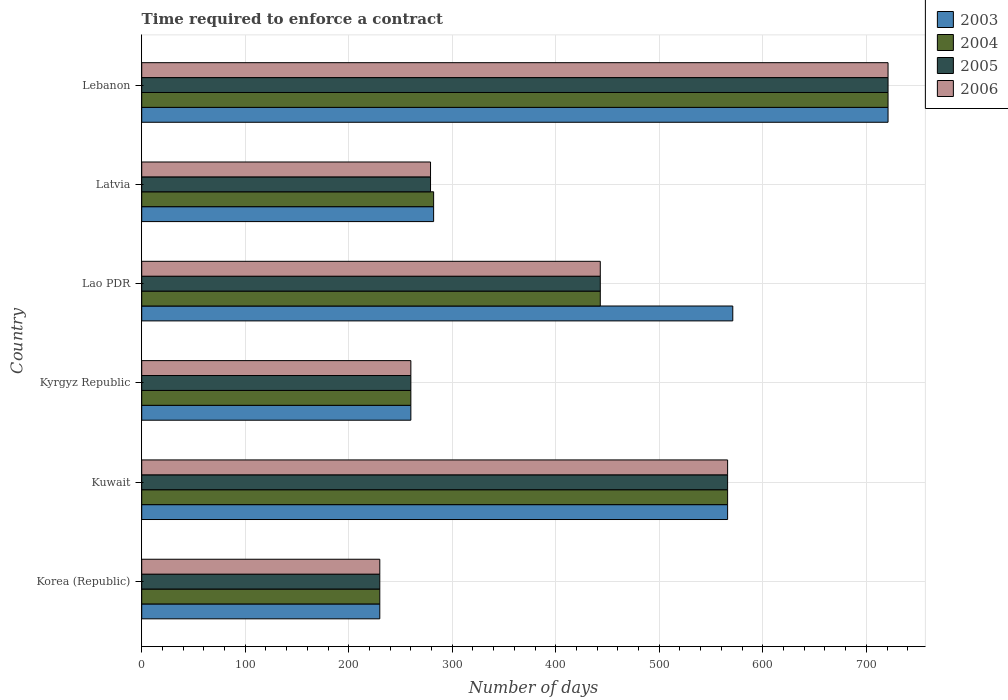How many different coloured bars are there?
Offer a terse response. 4. Are the number of bars per tick equal to the number of legend labels?
Provide a succinct answer. Yes. How many bars are there on the 1st tick from the top?
Your response must be concise. 4. How many bars are there on the 2nd tick from the bottom?
Make the answer very short. 4. What is the label of the 2nd group of bars from the top?
Your answer should be compact. Latvia. In how many cases, is the number of bars for a given country not equal to the number of legend labels?
Your answer should be very brief. 0. What is the number of days required to enforce a contract in 2005 in Lao PDR?
Make the answer very short. 443. Across all countries, what is the maximum number of days required to enforce a contract in 2005?
Offer a very short reply. 721. Across all countries, what is the minimum number of days required to enforce a contract in 2006?
Give a very brief answer. 230. In which country was the number of days required to enforce a contract in 2006 maximum?
Your answer should be very brief. Lebanon. In which country was the number of days required to enforce a contract in 2004 minimum?
Offer a very short reply. Korea (Republic). What is the total number of days required to enforce a contract in 2004 in the graph?
Keep it short and to the point. 2502. What is the difference between the number of days required to enforce a contract in 2006 in Kyrgyz Republic and that in Lebanon?
Keep it short and to the point. -461. What is the difference between the number of days required to enforce a contract in 2005 in Lao PDR and the number of days required to enforce a contract in 2006 in Latvia?
Offer a very short reply. 164. What is the average number of days required to enforce a contract in 2003 per country?
Offer a very short reply. 438.33. What is the difference between the number of days required to enforce a contract in 2006 and number of days required to enforce a contract in 2005 in Kyrgyz Republic?
Offer a terse response. 0. What is the ratio of the number of days required to enforce a contract in 2006 in Kyrgyz Republic to that in Lebanon?
Make the answer very short. 0.36. Is the number of days required to enforce a contract in 2004 in Kyrgyz Republic less than that in Lao PDR?
Keep it short and to the point. Yes. What is the difference between the highest and the second highest number of days required to enforce a contract in 2005?
Your response must be concise. 155. What is the difference between the highest and the lowest number of days required to enforce a contract in 2006?
Provide a succinct answer. 491. In how many countries, is the number of days required to enforce a contract in 2004 greater than the average number of days required to enforce a contract in 2004 taken over all countries?
Provide a short and direct response. 3. What does the 3rd bar from the top in Korea (Republic) represents?
Your answer should be very brief. 2004. Is it the case that in every country, the sum of the number of days required to enforce a contract in 2004 and number of days required to enforce a contract in 2005 is greater than the number of days required to enforce a contract in 2003?
Your response must be concise. Yes. How many countries are there in the graph?
Your response must be concise. 6. What is the difference between two consecutive major ticks on the X-axis?
Give a very brief answer. 100. Are the values on the major ticks of X-axis written in scientific E-notation?
Provide a short and direct response. No. Does the graph contain any zero values?
Your answer should be compact. No. Where does the legend appear in the graph?
Keep it short and to the point. Top right. How many legend labels are there?
Give a very brief answer. 4. What is the title of the graph?
Keep it short and to the point. Time required to enforce a contract. What is the label or title of the X-axis?
Provide a short and direct response. Number of days. What is the Number of days in 2003 in Korea (Republic)?
Offer a very short reply. 230. What is the Number of days of 2004 in Korea (Republic)?
Your answer should be compact. 230. What is the Number of days of 2005 in Korea (Republic)?
Offer a very short reply. 230. What is the Number of days in 2006 in Korea (Republic)?
Give a very brief answer. 230. What is the Number of days in 2003 in Kuwait?
Offer a terse response. 566. What is the Number of days of 2004 in Kuwait?
Your answer should be compact. 566. What is the Number of days of 2005 in Kuwait?
Keep it short and to the point. 566. What is the Number of days in 2006 in Kuwait?
Give a very brief answer. 566. What is the Number of days of 2003 in Kyrgyz Republic?
Make the answer very short. 260. What is the Number of days of 2004 in Kyrgyz Republic?
Keep it short and to the point. 260. What is the Number of days in 2005 in Kyrgyz Republic?
Your response must be concise. 260. What is the Number of days in 2006 in Kyrgyz Republic?
Keep it short and to the point. 260. What is the Number of days of 2003 in Lao PDR?
Keep it short and to the point. 571. What is the Number of days in 2004 in Lao PDR?
Provide a short and direct response. 443. What is the Number of days in 2005 in Lao PDR?
Offer a terse response. 443. What is the Number of days of 2006 in Lao PDR?
Ensure brevity in your answer.  443. What is the Number of days of 2003 in Latvia?
Provide a short and direct response. 282. What is the Number of days of 2004 in Latvia?
Make the answer very short. 282. What is the Number of days of 2005 in Latvia?
Your answer should be compact. 279. What is the Number of days of 2006 in Latvia?
Ensure brevity in your answer.  279. What is the Number of days of 2003 in Lebanon?
Offer a terse response. 721. What is the Number of days of 2004 in Lebanon?
Offer a very short reply. 721. What is the Number of days in 2005 in Lebanon?
Your response must be concise. 721. What is the Number of days in 2006 in Lebanon?
Provide a succinct answer. 721. Across all countries, what is the maximum Number of days in 2003?
Your answer should be compact. 721. Across all countries, what is the maximum Number of days in 2004?
Offer a very short reply. 721. Across all countries, what is the maximum Number of days of 2005?
Give a very brief answer. 721. Across all countries, what is the maximum Number of days of 2006?
Your response must be concise. 721. Across all countries, what is the minimum Number of days of 2003?
Provide a short and direct response. 230. Across all countries, what is the minimum Number of days in 2004?
Your response must be concise. 230. Across all countries, what is the minimum Number of days of 2005?
Keep it short and to the point. 230. Across all countries, what is the minimum Number of days in 2006?
Provide a succinct answer. 230. What is the total Number of days in 2003 in the graph?
Offer a terse response. 2630. What is the total Number of days in 2004 in the graph?
Offer a terse response. 2502. What is the total Number of days in 2005 in the graph?
Give a very brief answer. 2499. What is the total Number of days of 2006 in the graph?
Make the answer very short. 2499. What is the difference between the Number of days in 2003 in Korea (Republic) and that in Kuwait?
Give a very brief answer. -336. What is the difference between the Number of days in 2004 in Korea (Republic) and that in Kuwait?
Offer a terse response. -336. What is the difference between the Number of days of 2005 in Korea (Republic) and that in Kuwait?
Give a very brief answer. -336. What is the difference between the Number of days in 2006 in Korea (Republic) and that in Kuwait?
Provide a succinct answer. -336. What is the difference between the Number of days in 2005 in Korea (Republic) and that in Kyrgyz Republic?
Provide a short and direct response. -30. What is the difference between the Number of days of 2006 in Korea (Republic) and that in Kyrgyz Republic?
Ensure brevity in your answer.  -30. What is the difference between the Number of days of 2003 in Korea (Republic) and that in Lao PDR?
Make the answer very short. -341. What is the difference between the Number of days in 2004 in Korea (Republic) and that in Lao PDR?
Offer a very short reply. -213. What is the difference between the Number of days of 2005 in Korea (Republic) and that in Lao PDR?
Keep it short and to the point. -213. What is the difference between the Number of days in 2006 in Korea (Republic) and that in Lao PDR?
Your answer should be compact. -213. What is the difference between the Number of days of 2003 in Korea (Republic) and that in Latvia?
Your response must be concise. -52. What is the difference between the Number of days of 2004 in Korea (Republic) and that in Latvia?
Provide a short and direct response. -52. What is the difference between the Number of days in 2005 in Korea (Republic) and that in Latvia?
Offer a very short reply. -49. What is the difference between the Number of days in 2006 in Korea (Republic) and that in Latvia?
Offer a terse response. -49. What is the difference between the Number of days in 2003 in Korea (Republic) and that in Lebanon?
Provide a short and direct response. -491. What is the difference between the Number of days of 2004 in Korea (Republic) and that in Lebanon?
Ensure brevity in your answer.  -491. What is the difference between the Number of days of 2005 in Korea (Republic) and that in Lebanon?
Provide a short and direct response. -491. What is the difference between the Number of days of 2006 in Korea (Republic) and that in Lebanon?
Ensure brevity in your answer.  -491. What is the difference between the Number of days of 2003 in Kuwait and that in Kyrgyz Republic?
Your answer should be compact. 306. What is the difference between the Number of days of 2004 in Kuwait and that in Kyrgyz Republic?
Your answer should be very brief. 306. What is the difference between the Number of days in 2005 in Kuwait and that in Kyrgyz Republic?
Ensure brevity in your answer.  306. What is the difference between the Number of days in 2006 in Kuwait and that in Kyrgyz Republic?
Provide a short and direct response. 306. What is the difference between the Number of days of 2004 in Kuwait and that in Lao PDR?
Give a very brief answer. 123. What is the difference between the Number of days in 2005 in Kuwait and that in Lao PDR?
Offer a very short reply. 123. What is the difference between the Number of days in 2006 in Kuwait and that in Lao PDR?
Provide a succinct answer. 123. What is the difference between the Number of days of 2003 in Kuwait and that in Latvia?
Provide a short and direct response. 284. What is the difference between the Number of days in 2004 in Kuwait and that in Latvia?
Provide a succinct answer. 284. What is the difference between the Number of days in 2005 in Kuwait and that in Latvia?
Give a very brief answer. 287. What is the difference between the Number of days in 2006 in Kuwait and that in Latvia?
Give a very brief answer. 287. What is the difference between the Number of days of 2003 in Kuwait and that in Lebanon?
Provide a succinct answer. -155. What is the difference between the Number of days in 2004 in Kuwait and that in Lebanon?
Your response must be concise. -155. What is the difference between the Number of days of 2005 in Kuwait and that in Lebanon?
Provide a succinct answer. -155. What is the difference between the Number of days in 2006 in Kuwait and that in Lebanon?
Offer a terse response. -155. What is the difference between the Number of days of 2003 in Kyrgyz Republic and that in Lao PDR?
Your answer should be compact. -311. What is the difference between the Number of days of 2004 in Kyrgyz Republic and that in Lao PDR?
Your answer should be very brief. -183. What is the difference between the Number of days in 2005 in Kyrgyz Republic and that in Lao PDR?
Your response must be concise. -183. What is the difference between the Number of days of 2006 in Kyrgyz Republic and that in Lao PDR?
Your response must be concise. -183. What is the difference between the Number of days in 2003 in Kyrgyz Republic and that in Latvia?
Make the answer very short. -22. What is the difference between the Number of days in 2005 in Kyrgyz Republic and that in Latvia?
Give a very brief answer. -19. What is the difference between the Number of days in 2006 in Kyrgyz Republic and that in Latvia?
Make the answer very short. -19. What is the difference between the Number of days in 2003 in Kyrgyz Republic and that in Lebanon?
Provide a short and direct response. -461. What is the difference between the Number of days in 2004 in Kyrgyz Republic and that in Lebanon?
Provide a succinct answer. -461. What is the difference between the Number of days of 2005 in Kyrgyz Republic and that in Lebanon?
Offer a very short reply. -461. What is the difference between the Number of days in 2006 in Kyrgyz Republic and that in Lebanon?
Your response must be concise. -461. What is the difference between the Number of days of 2003 in Lao PDR and that in Latvia?
Provide a short and direct response. 289. What is the difference between the Number of days in 2004 in Lao PDR and that in Latvia?
Offer a very short reply. 161. What is the difference between the Number of days in 2005 in Lao PDR and that in Latvia?
Your answer should be very brief. 164. What is the difference between the Number of days of 2006 in Lao PDR and that in Latvia?
Provide a short and direct response. 164. What is the difference between the Number of days of 2003 in Lao PDR and that in Lebanon?
Provide a succinct answer. -150. What is the difference between the Number of days of 2004 in Lao PDR and that in Lebanon?
Offer a terse response. -278. What is the difference between the Number of days in 2005 in Lao PDR and that in Lebanon?
Ensure brevity in your answer.  -278. What is the difference between the Number of days of 2006 in Lao PDR and that in Lebanon?
Your response must be concise. -278. What is the difference between the Number of days of 2003 in Latvia and that in Lebanon?
Ensure brevity in your answer.  -439. What is the difference between the Number of days in 2004 in Latvia and that in Lebanon?
Your answer should be compact. -439. What is the difference between the Number of days in 2005 in Latvia and that in Lebanon?
Make the answer very short. -442. What is the difference between the Number of days of 2006 in Latvia and that in Lebanon?
Your answer should be very brief. -442. What is the difference between the Number of days in 2003 in Korea (Republic) and the Number of days in 2004 in Kuwait?
Your response must be concise. -336. What is the difference between the Number of days in 2003 in Korea (Republic) and the Number of days in 2005 in Kuwait?
Your response must be concise. -336. What is the difference between the Number of days in 2003 in Korea (Republic) and the Number of days in 2006 in Kuwait?
Your answer should be compact. -336. What is the difference between the Number of days in 2004 in Korea (Republic) and the Number of days in 2005 in Kuwait?
Your answer should be compact. -336. What is the difference between the Number of days in 2004 in Korea (Republic) and the Number of days in 2006 in Kuwait?
Ensure brevity in your answer.  -336. What is the difference between the Number of days in 2005 in Korea (Republic) and the Number of days in 2006 in Kuwait?
Provide a short and direct response. -336. What is the difference between the Number of days of 2003 in Korea (Republic) and the Number of days of 2005 in Kyrgyz Republic?
Give a very brief answer. -30. What is the difference between the Number of days of 2004 in Korea (Republic) and the Number of days of 2005 in Kyrgyz Republic?
Ensure brevity in your answer.  -30. What is the difference between the Number of days of 2003 in Korea (Republic) and the Number of days of 2004 in Lao PDR?
Offer a very short reply. -213. What is the difference between the Number of days in 2003 in Korea (Republic) and the Number of days in 2005 in Lao PDR?
Give a very brief answer. -213. What is the difference between the Number of days of 2003 in Korea (Republic) and the Number of days of 2006 in Lao PDR?
Your answer should be compact. -213. What is the difference between the Number of days in 2004 in Korea (Republic) and the Number of days in 2005 in Lao PDR?
Provide a short and direct response. -213. What is the difference between the Number of days in 2004 in Korea (Republic) and the Number of days in 2006 in Lao PDR?
Provide a succinct answer. -213. What is the difference between the Number of days in 2005 in Korea (Republic) and the Number of days in 2006 in Lao PDR?
Offer a terse response. -213. What is the difference between the Number of days in 2003 in Korea (Republic) and the Number of days in 2004 in Latvia?
Keep it short and to the point. -52. What is the difference between the Number of days in 2003 in Korea (Republic) and the Number of days in 2005 in Latvia?
Give a very brief answer. -49. What is the difference between the Number of days in 2003 in Korea (Republic) and the Number of days in 2006 in Latvia?
Provide a succinct answer. -49. What is the difference between the Number of days of 2004 in Korea (Republic) and the Number of days of 2005 in Latvia?
Keep it short and to the point. -49. What is the difference between the Number of days in 2004 in Korea (Republic) and the Number of days in 2006 in Latvia?
Provide a short and direct response. -49. What is the difference between the Number of days of 2005 in Korea (Republic) and the Number of days of 2006 in Latvia?
Keep it short and to the point. -49. What is the difference between the Number of days in 2003 in Korea (Republic) and the Number of days in 2004 in Lebanon?
Keep it short and to the point. -491. What is the difference between the Number of days of 2003 in Korea (Republic) and the Number of days of 2005 in Lebanon?
Give a very brief answer. -491. What is the difference between the Number of days of 2003 in Korea (Republic) and the Number of days of 2006 in Lebanon?
Your response must be concise. -491. What is the difference between the Number of days in 2004 in Korea (Republic) and the Number of days in 2005 in Lebanon?
Ensure brevity in your answer.  -491. What is the difference between the Number of days in 2004 in Korea (Republic) and the Number of days in 2006 in Lebanon?
Provide a short and direct response. -491. What is the difference between the Number of days in 2005 in Korea (Republic) and the Number of days in 2006 in Lebanon?
Your response must be concise. -491. What is the difference between the Number of days of 2003 in Kuwait and the Number of days of 2004 in Kyrgyz Republic?
Offer a very short reply. 306. What is the difference between the Number of days of 2003 in Kuwait and the Number of days of 2005 in Kyrgyz Republic?
Offer a very short reply. 306. What is the difference between the Number of days in 2003 in Kuwait and the Number of days in 2006 in Kyrgyz Republic?
Keep it short and to the point. 306. What is the difference between the Number of days in 2004 in Kuwait and the Number of days in 2005 in Kyrgyz Republic?
Keep it short and to the point. 306. What is the difference between the Number of days of 2004 in Kuwait and the Number of days of 2006 in Kyrgyz Republic?
Make the answer very short. 306. What is the difference between the Number of days in 2005 in Kuwait and the Number of days in 2006 in Kyrgyz Republic?
Your answer should be compact. 306. What is the difference between the Number of days in 2003 in Kuwait and the Number of days in 2004 in Lao PDR?
Keep it short and to the point. 123. What is the difference between the Number of days of 2003 in Kuwait and the Number of days of 2005 in Lao PDR?
Keep it short and to the point. 123. What is the difference between the Number of days in 2003 in Kuwait and the Number of days in 2006 in Lao PDR?
Your answer should be very brief. 123. What is the difference between the Number of days in 2004 in Kuwait and the Number of days in 2005 in Lao PDR?
Offer a terse response. 123. What is the difference between the Number of days of 2004 in Kuwait and the Number of days of 2006 in Lao PDR?
Offer a terse response. 123. What is the difference between the Number of days in 2005 in Kuwait and the Number of days in 2006 in Lao PDR?
Keep it short and to the point. 123. What is the difference between the Number of days of 2003 in Kuwait and the Number of days of 2004 in Latvia?
Your response must be concise. 284. What is the difference between the Number of days of 2003 in Kuwait and the Number of days of 2005 in Latvia?
Ensure brevity in your answer.  287. What is the difference between the Number of days of 2003 in Kuwait and the Number of days of 2006 in Latvia?
Your response must be concise. 287. What is the difference between the Number of days of 2004 in Kuwait and the Number of days of 2005 in Latvia?
Your response must be concise. 287. What is the difference between the Number of days of 2004 in Kuwait and the Number of days of 2006 in Latvia?
Offer a very short reply. 287. What is the difference between the Number of days of 2005 in Kuwait and the Number of days of 2006 in Latvia?
Offer a very short reply. 287. What is the difference between the Number of days of 2003 in Kuwait and the Number of days of 2004 in Lebanon?
Provide a succinct answer. -155. What is the difference between the Number of days of 2003 in Kuwait and the Number of days of 2005 in Lebanon?
Provide a short and direct response. -155. What is the difference between the Number of days of 2003 in Kuwait and the Number of days of 2006 in Lebanon?
Your response must be concise. -155. What is the difference between the Number of days in 2004 in Kuwait and the Number of days in 2005 in Lebanon?
Your answer should be compact. -155. What is the difference between the Number of days in 2004 in Kuwait and the Number of days in 2006 in Lebanon?
Keep it short and to the point. -155. What is the difference between the Number of days of 2005 in Kuwait and the Number of days of 2006 in Lebanon?
Your answer should be compact. -155. What is the difference between the Number of days of 2003 in Kyrgyz Republic and the Number of days of 2004 in Lao PDR?
Your response must be concise. -183. What is the difference between the Number of days in 2003 in Kyrgyz Republic and the Number of days in 2005 in Lao PDR?
Provide a succinct answer. -183. What is the difference between the Number of days in 2003 in Kyrgyz Republic and the Number of days in 2006 in Lao PDR?
Offer a terse response. -183. What is the difference between the Number of days in 2004 in Kyrgyz Republic and the Number of days in 2005 in Lao PDR?
Offer a terse response. -183. What is the difference between the Number of days of 2004 in Kyrgyz Republic and the Number of days of 2006 in Lao PDR?
Your answer should be very brief. -183. What is the difference between the Number of days in 2005 in Kyrgyz Republic and the Number of days in 2006 in Lao PDR?
Make the answer very short. -183. What is the difference between the Number of days in 2003 in Kyrgyz Republic and the Number of days in 2004 in Latvia?
Give a very brief answer. -22. What is the difference between the Number of days in 2003 in Kyrgyz Republic and the Number of days in 2006 in Latvia?
Provide a short and direct response. -19. What is the difference between the Number of days of 2005 in Kyrgyz Republic and the Number of days of 2006 in Latvia?
Make the answer very short. -19. What is the difference between the Number of days of 2003 in Kyrgyz Republic and the Number of days of 2004 in Lebanon?
Your answer should be very brief. -461. What is the difference between the Number of days in 2003 in Kyrgyz Republic and the Number of days in 2005 in Lebanon?
Ensure brevity in your answer.  -461. What is the difference between the Number of days in 2003 in Kyrgyz Republic and the Number of days in 2006 in Lebanon?
Your answer should be very brief. -461. What is the difference between the Number of days in 2004 in Kyrgyz Republic and the Number of days in 2005 in Lebanon?
Your answer should be compact. -461. What is the difference between the Number of days in 2004 in Kyrgyz Republic and the Number of days in 2006 in Lebanon?
Provide a short and direct response. -461. What is the difference between the Number of days in 2005 in Kyrgyz Republic and the Number of days in 2006 in Lebanon?
Ensure brevity in your answer.  -461. What is the difference between the Number of days of 2003 in Lao PDR and the Number of days of 2004 in Latvia?
Keep it short and to the point. 289. What is the difference between the Number of days in 2003 in Lao PDR and the Number of days in 2005 in Latvia?
Ensure brevity in your answer.  292. What is the difference between the Number of days of 2003 in Lao PDR and the Number of days of 2006 in Latvia?
Offer a very short reply. 292. What is the difference between the Number of days in 2004 in Lao PDR and the Number of days in 2005 in Latvia?
Offer a terse response. 164. What is the difference between the Number of days in 2004 in Lao PDR and the Number of days in 2006 in Latvia?
Ensure brevity in your answer.  164. What is the difference between the Number of days in 2005 in Lao PDR and the Number of days in 2006 in Latvia?
Offer a very short reply. 164. What is the difference between the Number of days of 2003 in Lao PDR and the Number of days of 2004 in Lebanon?
Provide a short and direct response. -150. What is the difference between the Number of days in 2003 in Lao PDR and the Number of days in 2005 in Lebanon?
Keep it short and to the point. -150. What is the difference between the Number of days in 2003 in Lao PDR and the Number of days in 2006 in Lebanon?
Make the answer very short. -150. What is the difference between the Number of days in 2004 in Lao PDR and the Number of days in 2005 in Lebanon?
Offer a terse response. -278. What is the difference between the Number of days of 2004 in Lao PDR and the Number of days of 2006 in Lebanon?
Make the answer very short. -278. What is the difference between the Number of days in 2005 in Lao PDR and the Number of days in 2006 in Lebanon?
Offer a very short reply. -278. What is the difference between the Number of days of 2003 in Latvia and the Number of days of 2004 in Lebanon?
Offer a terse response. -439. What is the difference between the Number of days in 2003 in Latvia and the Number of days in 2005 in Lebanon?
Offer a terse response. -439. What is the difference between the Number of days of 2003 in Latvia and the Number of days of 2006 in Lebanon?
Provide a succinct answer. -439. What is the difference between the Number of days of 2004 in Latvia and the Number of days of 2005 in Lebanon?
Your response must be concise. -439. What is the difference between the Number of days in 2004 in Latvia and the Number of days in 2006 in Lebanon?
Provide a short and direct response. -439. What is the difference between the Number of days of 2005 in Latvia and the Number of days of 2006 in Lebanon?
Your answer should be compact. -442. What is the average Number of days in 2003 per country?
Make the answer very short. 438.33. What is the average Number of days in 2004 per country?
Give a very brief answer. 417. What is the average Number of days of 2005 per country?
Provide a succinct answer. 416.5. What is the average Number of days of 2006 per country?
Keep it short and to the point. 416.5. What is the difference between the Number of days in 2003 and Number of days in 2004 in Korea (Republic)?
Ensure brevity in your answer.  0. What is the difference between the Number of days in 2004 and Number of days in 2006 in Korea (Republic)?
Ensure brevity in your answer.  0. What is the difference between the Number of days in 2005 and Number of days in 2006 in Korea (Republic)?
Your response must be concise. 0. What is the difference between the Number of days of 2003 and Number of days of 2004 in Kuwait?
Make the answer very short. 0. What is the difference between the Number of days in 2003 and Number of days in 2005 in Kuwait?
Give a very brief answer. 0. What is the difference between the Number of days of 2003 and Number of days of 2006 in Kuwait?
Provide a succinct answer. 0. What is the difference between the Number of days of 2003 and Number of days of 2004 in Kyrgyz Republic?
Provide a short and direct response. 0. What is the difference between the Number of days in 2003 and Number of days in 2005 in Kyrgyz Republic?
Provide a short and direct response. 0. What is the difference between the Number of days in 2004 and Number of days in 2006 in Kyrgyz Republic?
Give a very brief answer. 0. What is the difference between the Number of days in 2005 and Number of days in 2006 in Kyrgyz Republic?
Provide a short and direct response. 0. What is the difference between the Number of days in 2003 and Number of days in 2004 in Lao PDR?
Give a very brief answer. 128. What is the difference between the Number of days of 2003 and Number of days of 2005 in Lao PDR?
Make the answer very short. 128. What is the difference between the Number of days of 2003 and Number of days of 2006 in Lao PDR?
Give a very brief answer. 128. What is the difference between the Number of days in 2004 and Number of days in 2005 in Lao PDR?
Your answer should be very brief. 0. What is the difference between the Number of days in 2004 and Number of days in 2006 in Lao PDR?
Offer a very short reply. 0. What is the difference between the Number of days in 2003 and Number of days in 2004 in Latvia?
Your answer should be very brief. 0. What is the difference between the Number of days in 2004 and Number of days in 2006 in Latvia?
Your response must be concise. 3. What is the difference between the Number of days in 2004 and Number of days in 2005 in Lebanon?
Make the answer very short. 0. What is the difference between the Number of days of 2005 and Number of days of 2006 in Lebanon?
Give a very brief answer. 0. What is the ratio of the Number of days in 2003 in Korea (Republic) to that in Kuwait?
Keep it short and to the point. 0.41. What is the ratio of the Number of days in 2004 in Korea (Republic) to that in Kuwait?
Provide a short and direct response. 0.41. What is the ratio of the Number of days of 2005 in Korea (Republic) to that in Kuwait?
Make the answer very short. 0.41. What is the ratio of the Number of days of 2006 in Korea (Republic) to that in Kuwait?
Provide a short and direct response. 0.41. What is the ratio of the Number of days in 2003 in Korea (Republic) to that in Kyrgyz Republic?
Provide a succinct answer. 0.88. What is the ratio of the Number of days of 2004 in Korea (Republic) to that in Kyrgyz Republic?
Give a very brief answer. 0.88. What is the ratio of the Number of days in 2005 in Korea (Republic) to that in Kyrgyz Republic?
Your response must be concise. 0.88. What is the ratio of the Number of days of 2006 in Korea (Republic) to that in Kyrgyz Republic?
Your answer should be compact. 0.88. What is the ratio of the Number of days in 2003 in Korea (Republic) to that in Lao PDR?
Make the answer very short. 0.4. What is the ratio of the Number of days in 2004 in Korea (Republic) to that in Lao PDR?
Ensure brevity in your answer.  0.52. What is the ratio of the Number of days in 2005 in Korea (Republic) to that in Lao PDR?
Your response must be concise. 0.52. What is the ratio of the Number of days of 2006 in Korea (Republic) to that in Lao PDR?
Provide a succinct answer. 0.52. What is the ratio of the Number of days of 2003 in Korea (Republic) to that in Latvia?
Ensure brevity in your answer.  0.82. What is the ratio of the Number of days of 2004 in Korea (Republic) to that in Latvia?
Provide a succinct answer. 0.82. What is the ratio of the Number of days in 2005 in Korea (Republic) to that in Latvia?
Offer a terse response. 0.82. What is the ratio of the Number of days in 2006 in Korea (Republic) to that in Latvia?
Your answer should be compact. 0.82. What is the ratio of the Number of days of 2003 in Korea (Republic) to that in Lebanon?
Your answer should be very brief. 0.32. What is the ratio of the Number of days of 2004 in Korea (Republic) to that in Lebanon?
Provide a succinct answer. 0.32. What is the ratio of the Number of days of 2005 in Korea (Republic) to that in Lebanon?
Offer a terse response. 0.32. What is the ratio of the Number of days in 2006 in Korea (Republic) to that in Lebanon?
Offer a terse response. 0.32. What is the ratio of the Number of days in 2003 in Kuwait to that in Kyrgyz Republic?
Your answer should be very brief. 2.18. What is the ratio of the Number of days in 2004 in Kuwait to that in Kyrgyz Republic?
Ensure brevity in your answer.  2.18. What is the ratio of the Number of days in 2005 in Kuwait to that in Kyrgyz Republic?
Give a very brief answer. 2.18. What is the ratio of the Number of days in 2006 in Kuwait to that in Kyrgyz Republic?
Provide a short and direct response. 2.18. What is the ratio of the Number of days in 2003 in Kuwait to that in Lao PDR?
Your answer should be very brief. 0.99. What is the ratio of the Number of days of 2004 in Kuwait to that in Lao PDR?
Your answer should be compact. 1.28. What is the ratio of the Number of days in 2005 in Kuwait to that in Lao PDR?
Your answer should be very brief. 1.28. What is the ratio of the Number of days in 2006 in Kuwait to that in Lao PDR?
Provide a succinct answer. 1.28. What is the ratio of the Number of days in 2003 in Kuwait to that in Latvia?
Ensure brevity in your answer.  2.01. What is the ratio of the Number of days in 2004 in Kuwait to that in Latvia?
Your response must be concise. 2.01. What is the ratio of the Number of days in 2005 in Kuwait to that in Latvia?
Your answer should be very brief. 2.03. What is the ratio of the Number of days in 2006 in Kuwait to that in Latvia?
Make the answer very short. 2.03. What is the ratio of the Number of days in 2003 in Kuwait to that in Lebanon?
Make the answer very short. 0.79. What is the ratio of the Number of days in 2004 in Kuwait to that in Lebanon?
Keep it short and to the point. 0.79. What is the ratio of the Number of days of 2005 in Kuwait to that in Lebanon?
Offer a very short reply. 0.79. What is the ratio of the Number of days of 2006 in Kuwait to that in Lebanon?
Offer a very short reply. 0.79. What is the ratio of the Number of days in 2003 in Kyrgyz Republic to that in Lao PDR?
Keep it short and to the point. 0.46. What is the ratio of the Number of days in 2004 in Kyrgyz Republic to that in Lao PDR?
Offer a very short reply. 0.59. What is the ratio of the Number of days of 2005 in Kyrgyz Republic to that in Lao PDR?
Make the answer very short. 0.59. What is the ratio of the Number of days in 2006 in Kyrgyz Republic to that in Lao PDR?
Offer a terse response. 0.59. What is the ratio of the Number of days in 2003 in Kyrgyz Republic to that in Latvia?
Offer a terse response. 0.92. What is the ratio of the Number of days of 2004 in Kyrgyz Republic to that in Latvia?
Make the answer very short. 0.92. What is the ratio of the Number of days in 2005 in Kyrgyz Republic to that in Latvia?
Your answer should be very brief. 0.93. What is the ratio of the Number of days of 2006 in Kyrgyz Republic to that in Latvia?
Provide a short and direct response. 0.93. What is the ratio of the Number of days of 2003 in Kyrgyz Republic to that in Lebanon?
Give a very brief answer. 0.36. What is the ratio of the Number of days of 2004 in Kyrgyz Republic to that in Lebanon?
Your response must be concise. 0.36. What is the ratio of the Number of days of 2005 in Kyrgyz Republic to that in Lebanon?
Provide a succinct answer. 0.36. What is the ratio of the Number of days in 2006 in Kyrgyz Republic to that in Lebanon?
Make the answer very short. 0.36. What is the ratio of the Number of days in 2003 in Lao PDR to that in Latvia?
Offer a very short reply. 2.02. What is the ratio of the Number of days of 2004 in Lao PDR to that in Latvia?
Offer a very short reply. 1.57. What is the ratio of the Number of days of 2005 in Lao PDR to that in Latvia?
Your answer should be compact. 1.59. What is the ratio of the Number of days in 2006 in Lao PDR to that in Latvia?
Offer a terse response. 1.59. What is the ratio of the Number of days in 2003 in Lao PDR to that in Lebanon?
Offer a very short reply. 0.79. What is the ratio of the Number of days of 2004 in Lao PDR to that in Lebanon?
Provide a succinct answer. 0.61. What is the ratio of the Number of days of 2005 in Lao PDR to that in Lebanon?
Your answer should be compact. 0.61. What is the ratio of the Number of days of 2006 in Lao PDR to that in Lebanon?
Your answer should be very brief. 0.61. What is the ratio of the Number of days in 2003 in Latvia to that in Lebanon?
Offer a terse response. 0.39. What is the ratio of the Number of days in 2004 in Latvia to that in Lebanon?
Offer a very short reply. 0.39. What is the ratio of the Number of days in 2005 in Latvia to that in Lebanon?
Give a very brief answer. 0.39. What is the ratio of the Number of days of 2006 in Latvia to that in Lebanon?
Provide a succinct answer. 0.39. What is the difference between the highest and the second highest Number of days of 2003?
Your answer should be very brief. 150. What is the difference between the highest and the second highest Number of days in 2004?
Keep it short and to the point. 155. What is the difference between the highest and the second highest Number of days of 2005?
Provide a succinct answer. 155. What is the difference between the highest and the second highest Number of days of 2006?
Your response must be concise. 155. What is the difference between the highest and the lowest Number of days in 2003?
Your response must be concise. 491. What is the difference between the highest and the lowest Number of days of 2004?
Ensure brevity in your answer.  491. What is the difference between the highest and the lowest Number of days in 2005?
Your answer should be compact. 491. What is the difference between the highest and the lowest Number of days in 2006?
Offer a very short reply. 491. 